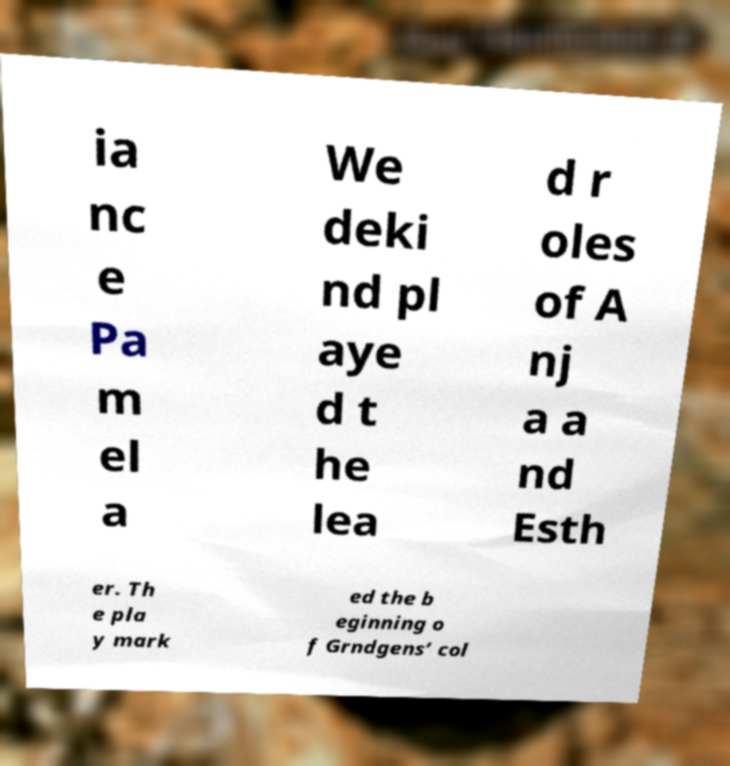Please identify and transcribe the text found in this image. ia nc e Pa m el a We deki nd pl aye d t he lea d r oles of A nj a a nd Esth er. Th e pla y mark ed the b eginning o f Grndgens’ col 